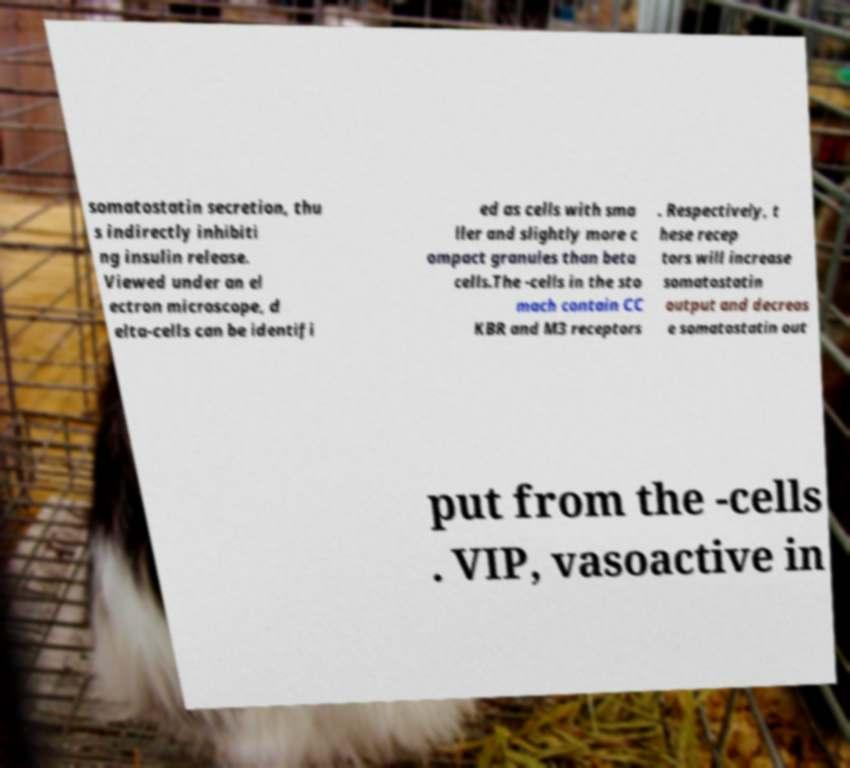Could you extract and type out the text from this image? somatostatin secretion, thu s indirectly inhibiti ng insulin release. Viewed under an el ectron microscope, d elta-cells can be identifi ed as cells with sma ller and slightly more c ompact granules than beta cells.The -cells in the sto mach contain CC KBR and M3 receptors . Respectively, t hese recep tors will increase somatostatin output and decreas e somatostatin out put from the -cells . VIP, vasoactive in 